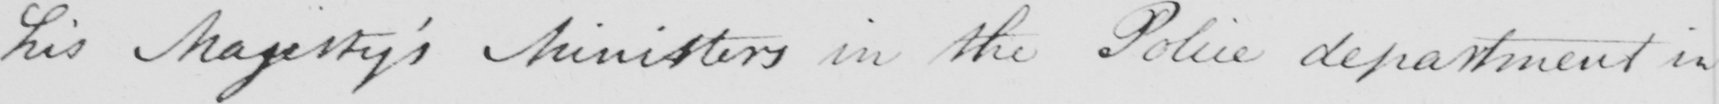What does this handwritten line say? his Majesty ' s Ministers in the Police department in 